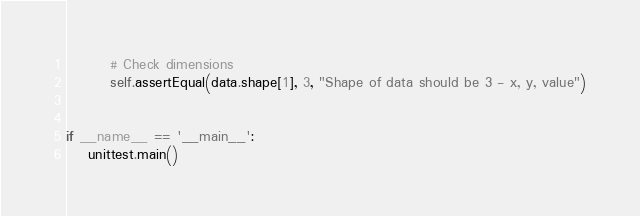<code> <loc_0><loc_0><loc_500><loc_500><_Python_>		# Check dimensions
		self.assertEqual(data.shape[1], 3, "Shape of data should be 3 - x, y, value")


if __name__ == '__main__':
	unittest.main()
</code> 